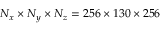Convert formula to latex. <formula><loc_0><loc_0><loc_500><loc_500>N _ { x } \times N _ { y } \times N _ { z } = 2 5 6 \times 1 3 0 \times 2 5 6</formula> 